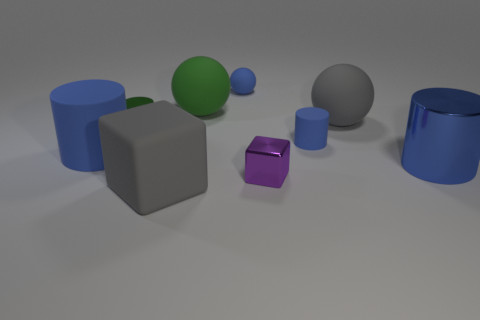How many large objects are purple shiny blocks or blue matte cylinders?
Provide a short and direct response. 1. There is a big object that is both to the right of the big rubber block and in front of the tiny green cylinder; what material is it made of?
Make the answer very short. Metal. Do the small metallic thing right of the blue matte sphere and the big gray rubber object that is in front of the metal block have the same shape?
Keep it short and to the point. Yes. There is a big object that is the same color as the tiny metal cylinder; what is its shape?
Provide a short and direct response. Sphere. What number of things are big cylinders that are on the left side of the big blue metallic object or green rubber cylinders?
Your answer should be compact. 1. Do the blue shiny object and the green shiny thing have the same size?
Your response must be concise. No. There is a large matte thing that is in front of the tiny cube; what is its color?
Provide a succinct answer. Gray. There is a green cylinder that is made of the same material as the tiny cube; what size is it?
Your answer should be very brief. Small. There is a blue shiny thing; is its size the same as the purple cube in front of the tiny green cylinder?
Keep it short and to the point. No. There is a blue thing that is on the left side of the green shiny object; what is it made of?
Your response must be concise. Rubber. 